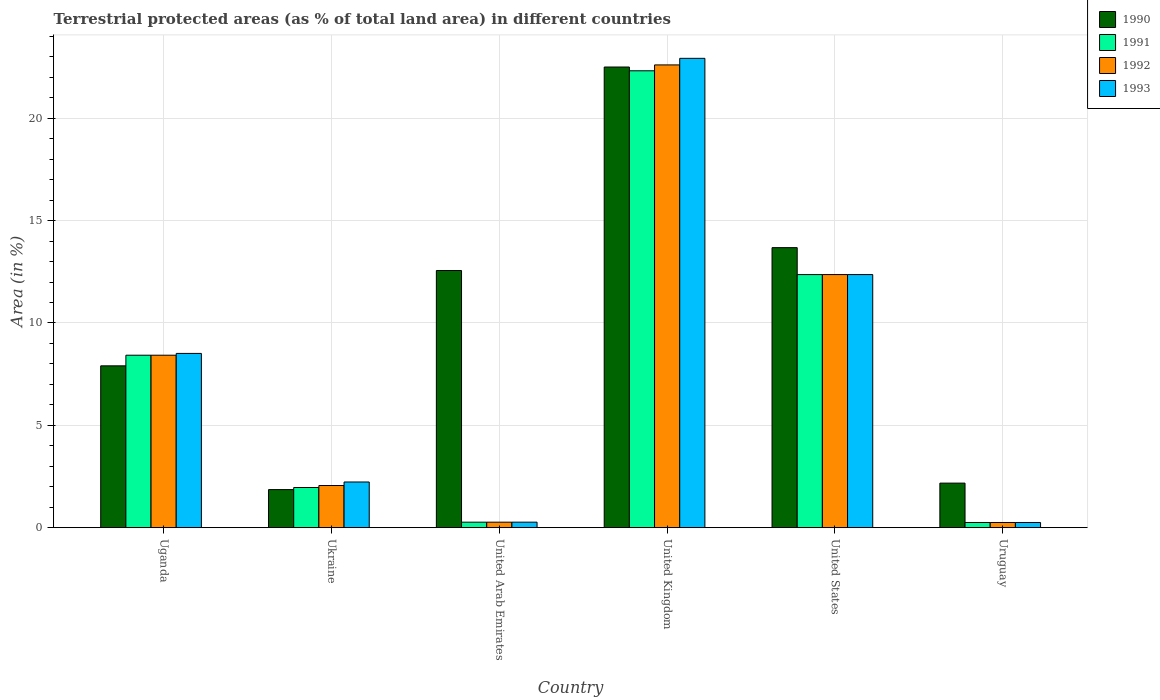How many groups of bars are there?
Provide a short and direct response. 6. Are the number of bars on each tick of the X-axis equal?
Provide a succinct answer. Yes. How many bars are there on the 4th tick from the left?
Make the answer very short. 4. In how many cases, is the number of bars for a given country not equal to the number of legend labels?
Your answer should be compact. 0. What is the percentage of terrestrial protected land in 1991 in Ukraine?
Make the answer very short. 1.96. Across all countries, what is the maximum percentage of terrestrial protected land in 1991?
Give a very brief answer. 22.32. Across all countries, what is the minimum percentage of terrestrial protected land in 1990?
Your response must be concise. 1.86. In which country was the percentage of terrestrial protected land in 1992 maximum?
Offer a very short reply. United Kingdom. In which country was the percentage of terrestrial protected land in 1993 minimum?
Your response must be concise. Uruguay. What is the total percentage of terrestrial protected land in 1991 in the graph?
Your response must be concise. 45.59. What is the difference between the percentage of terrestrial protected land in 1992 in Uganda and that in United Kingdom?
Your answer should be compact. -14.18. What is the difference between the percentage of terrestrial protected land in 1992 in Uruguay and the percentage of terrestrial protected land in 1990 in United States?
Your answer should be very brief. -13.43. What is the average percentage of terrestrial protected land in 1991 per country?
Offer a very short reply. 7.6. What is the difference between the percentage of terrestrial protected land of/in 1991 and percentage of terrestrial protected land of/in 1993 in United Arab Emirates?
Provide a succinct answer. -0. What is the ratio of the percentage of terrestrial protected land in 1990 in Ukraine to that in United Kingdom?
Provide a short and direct response. 0.08. Is the difference between the percentage of terrestrial protected land in 1991 in United Arab Emirates and United Kingdom greater than the difference between the percentage of terrestrial protected land in 1993 in United Arab Emirates and United Kingdom?
Ensure brevity in your answer.  Yes. What is the difference between the highest and the second highest percentage of terrestrial protected land in 1990?
Your response must be concise. -1.12. What is the difference between the highest and the lowest percentage of terrestrial protected land in 1993?
Your answer should be very brief. 22.68. What does the 4th bar from the left in Uruguay represents?
Your response must be concise. 1993. How many bars are there?
Provide a succinct answer. 24. How many countries are there in the graph?
Provide a succinct answer. 6. What is the difference between two consecutive major ticks on the Y-axis?
Offer a terse response. 5. How many legend labels are there?
Provide a short and direct response. 4. What is the title of the graph?
Your answer should be very brief. Terrestrial protected areas (as % of total land area) in different countries. Does "2007" appear as one of the legend labels in the graph?
Offer a terse response. No. What is the label or title of the X-axis?
Ensure brevity in your answer.  Country. What is the label or title of the Y-axis?
Make the answer very short. Area (in %). What is the Area (in %) of 1990 in Uganda?
Your response must be concise. 7.91. What is the Area (in %) in 1991 in Uganda?
Make the answer very short. 8.43. What is the Area (in %) of 1992 in Uganda?
Give a very brief answer. 8.43. What is the Area (in %) in 1993 in Uganda?
Make the answer very short. 8.51. What is the Area (in %) of 1990 in Ukraine?
Ensure brevity in your answer.  1.86. What is the Area (in %) in 1991 in Ukraine?
Provide a succinct answer. 1.96. What is the Area (in %) in 1992 in Ukraine?
Your answer should be compact. 2.06. What is the Area (in %) in 1993 in Ukraine?
Provide a short and direct response. 2.23. What is the Area (in %) of 1990 in United Arab Emirates?
Your answer should be compact. 12.56. What is the Area (in %) of 1991 in United Arab Emirates?
Make the answer very short. 0.27. What is the Area (in %) of 1992 in United Arab Emirates?
Offer a terse response. 0.27. What is the Area (in %) of 1993 in United Arab Emirates?
Keep it short and to the point. 0.27. What is the Area (in %) in 1990 in United Kingdom?
Give a very brief answer. 22.51. What is the Area (in %) of 1991 in United Kingdom?
Provide a short and direct response. 22.32. What is the Area (in %) of 1992 in United Kingdom?
Ensure brevity in your answer.  22.61. What is the Area (in %) in 1993 in United Kingdom?
Give a very brief answer. 22.93. What is the Area (in %) in 1990 in United States?
Give a very brief answer. 13.68. What is the Area (in %) in 1991 in United States?
Give a very brief answer. 12.36. What is the Area (in %) of 1992 in United States?
Provide a short and direct response. 12.36. What is the Area (in %) in 1993 in United States?
Offer a very short reply. 12.37. What is the Area (in %) of 1990 in Uruguay?
Your answer should be compact. 2.18. What is the Area (in %) in 1991 in Uruguay?
Make the answer very short. 0.25. What is the Area (in %) of 1992 in Uruguay?
Offer a terse response. 0.25. What is the Area (in %) in 1993 in Uruguay?
Offer a very short reply. 0.25. Across all countries, what is the maximum Area (in %) in 1990?
Your answer should be very brief. 22.51. Across all countries, what is the maximum Area (in %) of 1991?
Offer a terse response. 22.32. Across all countries, what is the maximum Area (in %) in 1992?
Your answer should be compact. 22.61. Across all countries, what is the maximum Area (in %) in 1993?
Provide a short and direct response. 22.93. Across all countries, what is the minimum Area (in %) in 1990?
Give a very brief answer. 1.86. Across all countries, what is the minimum Area (in %) of 1991?
Provide a short and direct response. 0.25. Across all countries, what is the minimum Area (in %) in 1992?
Provide a short and direct response. 0.25. Across all countries, what is the minimum Area (in %) in 1993?
Make the answer very short. 0.25. What is the total Area (in %) of 1990 in the graph?
Provide a short and direct response. 60.69. What is the total Area (in %) of 1991 in the graph?
Your answer should be compact. 45.59. What is the total Area (in %) in 1992 in the graph?
Ensure brevity in your answer.  45.97. What is the total Area (in %) of 1993 in the graph?
Provide a short and direct response. 46.56. What is the difference between the Area (in %) in 1990 in Uganda and that in Ukraine?
Offer a terse response. 6.05. What is the difference between the Area (in %) in 1991 in Uganda and that in Ukraine?
Your answer should be very brief. 6.46. What is the difference between the Area (in %) of 1992 in Uganda and that in Ukraine?
Keep it short and to the point. 6.37. What is the difference between the Area (in %) of 1993 in Uganda and that in Ukraine?
Make the answer very short. 6.28. What is the difference between the Area (in %) of 1990 in Uganda and that in United Arab Emirates?
Ensure brevity in your answer.  -4.66. What is the difference between the Area (in %) of 1991 in Uganda and that in United Arab Emirates?
Your response must be concise. 8.16. What is the difference between the Area (in %) of 1992 in Uganda and that in United Arab Emirates?
Your answer should be very brief. 8.16. What is the difference between the Area (in %) in 1993 in Uganda and that in United Arab Emirates?
Give a very brief answer. 8.25. What is the difference between the Area (in %) of 1990 in Uganda and that in United Kingdom?
Ensure brevity in your answer.  -14.6. What is the difference between the Area (in %) of 1991 in Uganda and that in United Kingdom?
Provide a short and direct response. -13.9. What is the difference between the Area (in %) in 1992 in Uganda and that in United Kingdom?
Provide a succinct answer. -14.18. What is the difference between the Area (in %) of 1993 in Uganda and that in United Kingdom?
Provide a succinct answer. -14.42. What is the difference between the Area (in %) of 1990 in Uganda and that in United States?
Your response must be concise. -5.77. What is the difference between the Area (in %) in 1991 in Uganda and that in United States?
Give a very brief answer. -3.94. What is the difference between the Area (in %) of 1992 in Uganda and that in United States?
Provide a short and direct response. -3.94. What is the difference between the Area (in %) of 1993 in Uganda and that in United States?
Your answer should be very brief. -3.85. What is the difference between the Area (in %) of 1990 in Uganda and that in Uruguay?
Provide a short and direct response. 5.73. What is the difference between the Area (in %) in 1991 in Uganda and that in Uruguay?
Provide a succinct answer. 8.17. What is the difference between the Area (in %) of 1992 in Uganda and that in Uruguay?
Your answer should be compact. 8.17. What is the difference between the Area (in %) in 1993 in Uganda and that in Uruguay?
Provide a succinct answer. 8.26. What is the difference between the Area (in %) of 1990 in Ukraine and that in United Arab Emirates?
Give a very brief answer. -10.7. What is the difference between the Area (in %) in 1991 in Ukraine and that in United Arab Emirates?
Your response must be concise. 1.69. What is the difference between the Area (in %) of 1992 in Ukraine and that in United Arab Emirates?
Keep it short and to the point. 1.79. What is the difference between the Area (in %) of 1993 in Ukraine and that in United Arab Emirates?
Provide a short and direct response. 1.96. What is the difference between the Area (in %) of 1990 in Ukraine and that in United Kingdom?
Your response must be concise. -20.65. What is the difference between the Area (in %) in 1991 in Ukraine and that in United Kingdom?
Give a very brief answer. -20.36. What is the difference between the Area (in %) in 1992 in Ukraine and that in United Kingdom?
Give a very brief answer. -20.55. What is the difference between the Area (in %) of 1993 in Ukraine and that in United Kingdom?
Your answer should be very brief. -20.7. What is the difference between the Area (in %) in 1990 in Ukraine and that in United States?
Keep it short and to the point. -11.82. What is the difference between the Area (in %) in 1991 in Ukraine and that in United States?
Your answer should be compact. -10.4. What is the difference between the Area (in %) in 1992 in Ukraine and that in United States?
Provide a succinct answer. -10.31. What is the difference between the Area (in %) of 1993 in Ukraine and that in United States?
Your answer should be compact. -10.13. What is the difference between the Area (in %) of 1990 in Ukraine and that in Uruguay?
Your answer should be compact. -0.32. What is the difference between the Area (in %) of 1991 in Ukraine and that in Uruguay?
Provide a succinct answer. 1.71. What is the difference between the Area (in %) in 1992 in Ukraine and that in Uruguay?
Your answer should be compact. 1.81. What is the difference between the Area (in %) in 1993 in Ukraine and that in Uruguay?
Provide a succinct answer. 1.98. What is the difference between the Area (in %) in 1990 in United Arab Emirates and that in United Kingdom?
Give a very brief answer. -9.94. What is the difference between the Area (in %) in 1991 in United Arab Emirates and that in United Kingdom?
Your response must be concise. -22.05. What is the difference between the Area (in %) in 1992 in United Arab Emirates and that in United Kingdom?
Your answer should be compact. -22.34. What is the difference between the Area (in %) of 1993 in United Arab Emirates and that in United Kingdom?
Provide a short and direct response. -22.66. What is the difference between the Area (in %) of 1990 in United Arab Emirates and that in United States?
Make the answer very short. -1.12. What is the difference between the Area (in %) in 1991 in United Arab Emirates and that in United States?
Provide a short and direct response. -12.1. What is the difference between the Area (in %) in 1992 in United Arab Emirates and that in United States?
Ensure brevity in your answer.  -12.1. What is the difference between the Area (in %) of 1993 in United Arab Emirates and that in United States?
Offer a very short reply. -12.1. What is the difference between the Area (in %) in 1990 in United Arab Emirates and that in Uruguay?
Provide a succinct answer. 10.39. What is the difference between the Area (in %) of 1991 in United Arab Emirates and that in Uruguay?
Make the answer very short. 0.02. What is the difference between the Area (in %) of 1992 in United Arab Emirates and that in Uruguay?
Give a very brief answer. 0.02. What is the difference between the Area (in %) in 1993 in United Arab Emirates and that in Uruguay?
Your answer should be very brief. 0.02. What is the difference between the Area (in %) in 1990 in United Kingdom and that in United States?
Your response must be concise. 8.83. What is the difference between the Area (in %) in 1991 in United Kingdom and that in United States?
Give a very brief answer. 9.96. What is the difference between the Area (in %) of 1992 in United Kingdom and that in United States?
Make the answer very short. 10.24. What is the difference between the Area (in %) of 1993 in United Kingdom and that in United States?
Offer a very short reply. 10.56. What is the difference between the Area (in %) of 1990 in United Kingdom and that in Uruguay?
Your answer should be very brief. 20.33. What is the difference between the Area (in %) of 1991 in United Kingdom and that in Uruguay?
Your answer should be very brief. 22.07. What is the difference between the Area (in %) in 1992 in United Kingdom and that in Uruguay?
Offer a terse response. 22.36. What is the difference between the Area (in %) in 1993 in United Kingdom and that in Uruguay?
Your answer should be compact. 22.68. What is the difference between the Area (in %) of 1990 in United States and that in Uruguay?
Keep it short and to the point. 11.5. What is the difference between the Area (in %) of 1991 in United States and that in Uruguay?
Ensure brevity in your answer.  12.11. What is the difference between the Area (in %) of 1992 in United States and that in Uruguay?
Keep it short and to the point. 12.11. What is the difference between the Area (in %) of 1993 in United States and that in Uruguay?
Keep it short and to the point. 12.11. What is the difference between the Area (in %) of 1990 in Uganda and the Area (in %) of 1991 in Ukraine?
Ensure brevity in your answer.  5.94. What is the difference between the Area (in %) of 1990 in Uganda and the Area (in %) of 1992 in Ukraine?
Ensure brevity in your answer.  5.85. What is the difference between the Area (in %) of 1990 in Uganda and the Area (in %) of 1993 in Ukraine?
Keep it short and to the point. 5.68. What is the difference between the Area (in %) in 1991 in Uganda and the Area (in %) in 1992 in Ukraine?
Offer a very short reply. 6.37. What is the difference between the Area (in %) of 1991 in Uganda and the Area (in %) of 1993 in Ukraine?
Provide a succinct answer. 6.19. What is the difference between the Area (in %) in 1992 in Uganda and the Area (in %) in 1993 in Ukraine?
Your response must be concise. 6.19. What is the difference between the Area (in %) of 1990 in Uganda and the Area (in %) of 1991 in United Arab Emirates?
Your answer should be very brief. 7.64. What is the difference between the Area (in %) in 1990 in Uganda and the Area (in %) in 1992 in United Arab Emirates?
Ensure brevity in your answer.  7.64. What is the difference between the Area (in %) in 1990 in Uganda and the Area (in %) in 1993 in United Arab Emirates?
Provide a succinct answer. 7.64. What is the difference between the Area (in %) in 1991 in Uganda and the Area (in %) in 1992 in United Arab Emirates?
Your response must be concise. 8.16. What is the difference between the Area (in %) in 1991 in Uganda and the Area (in %) in 1993 in United Arab Emirates?
Your answer should be compact. 8.16. What is the difference between the Area (in %) of 1992 in Uganda and the Area (in %) of 1993 in United Arab Emirates?
Offer a very short reply. 8.16. What is the difference between the Area (in %) of 1990 in Uganda and the Area (in %) of 1991 in United Kingdom?
Offer a terse response. -14.42. What is the difference between the Area (in %) of 1990 in Uganda and the Area (in %) of 1992 in United Kingdom?
Give a very brief answer. -14.7. What is the difference between the Area (in %) in 1990 in Uganda and the Area (in %) in 1993 in United Kingdom?
Offer a terse response. -15.02. What is the difference between the Area (in %) in 1991 in Uganda and the Area (in %) in 1992 in United Kingdom?
Make the answer very short. -14.18. What is the difference between the Area (in %) in 1991 in Uganda and the Area (in %) in 1993 in United Kingdom?
Make the answer very short. -14.5. What is the difference between the Area (in %) of 1992 in Uganda and the Area (in %) of 1993 in United Kingdom?
Give a very brief answer. -14.5. What is the difference between the Area (in %) in 1990 in Uganda and the Area (in %) in 1991 in United States?
Give a very brief answer. -4.46. What is the difference between the Area (in %) in 1990 in Uganda and the Area (in %) in 1992 in United States?
Your answer should be very brief. -4.46. What is the difference between the Area (in %) of 1990 in Uganda and the Area (in %) of 1993 in United States?
Your answer should be very brief. -4.46. What is the difference between the Area (in %) in 1991 in Uganda and the Area (in %) in 1992 in United States?
Ensure brevity in your answer.  -3.94. What is the difference between the Area (in %) in 1991 in Uganda and the Area (in %) in 1993 in United States?
Provide a short and direct response. -3.94. What is the difference between the Area (in %) of 1992 in Uganda and the Area (in %) of 1993 in United States?
Provide a succinct answer. -3.94. What is the difference between the Area (in %) in 1990 in Uganda and the Area (in %) in 1991 in Uruguay?
Ensure brevity in your answer.  7.65. What is the difference between the Area (in %) of 1990 in Uganda and the Area (in %) of 1992 in Uruguay?
Your answer should be compact. 7.65. What is the difference between the Area (in %) of 1990 in Uganda and the Area (in %) of 1993 in Uruguay?
Your answer should be very brief. 7.65. What is the difference between the Area (in %) in 1991 in Uganda and the Area (in %) in 1992 in Uruguay?
Provide a succinct answer. 8.17. What is the difference between the Area (in %) of 1991 in Uganda and the Area (in %) of 1993 in Uruguay?
Offer a terse response. 8.17. What is the difference between the Area (in %) in 1992 in Uganda and the Area (in %) in 1993 in Uruguay?
Your answer should be compact. 8.17. What is the difference between the Area (in %) in 1990 in Ukraine and the Area (in %) in 1991 in United Arab Emirates?
Make the answer very short. 1.59. What is the difference between the Area (in %) in 1990 in Ukraine and the Area (in %) in 1992 in United Arab Emirates?
Ensure brevity in your answer.  1.59. What is the difference between the Area (in %) of 1990 in Ukraine and the Area (in %) of 1993 in United Arab Emirates?
Offer a very short reply. 1.59. What is the difference between the Area (in %) in 1991 in Ukraine and the Area (in %) in 1992 in United Arab Emirates?
Provide a short and direct response. 1.69. What is the difference between the Area (in %) of 1991 in Ukraine and the Area (in %) of 1993 in United Arab Emirates?
Your answer should be very brief. 1.69. What is the difference between the Area (in %) of 1992 in Ukraine and the Area (in %) of 1993 in United Arab Emirates?
Your answer should be very brief. 1.79. What is the difference between the Area (in %) of 1990 in Ukraine and the Area (in %) of 1991 in United Kingdom?
Ensure brevity in your answer.  -20.46. What is the difference between the Area (in %) of 1990 in Ukraine and the Area (in %) of 1992 in United Kingdom?
Your answer should be very brief. -20.75. What is the difference between the Area (in %) in 1990 in Ukraine and the Area (in %) in 1993 in United Kingdom?
Make the answer very short. -21.07. What is the difference between the Area (in %) of 1991 in Ukraine and the Area (in %) of 1992 in United Kingdom?
Your answer should be very brief. -20.65. What is the difference between the Area (in %) in 1991 in Ukraine and the Area (in %) in 1993 in United Kingdom?
Your answer should be compact. -20.97. What is the difference between the Area (in %) in 1992 in Ukraine and the Area (in %) in 1993 in United Kingdom?
Your answer should be very brief. -20.87. What is the difference between the Area (in %) of 1990 in Ukraine and the Area (in %) of 1991 in United States?
Offer a very short reply. -10.5. What is the difference between the Area (in %) of 1990 in Ukraine and the Area (in %) of 1992 in United States?
Keep it short and to the point. -10.51. What is the difference between the Area (in %) of 1990 in Ukraine and the Area (in %) of 1993 in United States?
Make the answer very short. -10.51. What is the difference between the Area (in %) of 1991 in Ukraine and the Area (in %) of 1992 in United States?
Keep it short and to the point. -10.4. What is the difference between the Area (in %) in 1991 in Ukraine and the Area (in %) in 1993 in United States?
Ensure brevity in your answer.  -10.4. What is the difference between the Area (in %) of 1992 in Ukraine and the Area (in %) of 1993 in United States?
Make the answer very short. -10.31. What is the difference between the Area (in %) of 1990 in Ukraine and the Area (in %) of 1991 in Uruguay?
Offer a very short reply. 1.61. What is the difference between the Area (in %) of 1990 in Ukraine and the Area (in %) of 1992 in Uruguay?
Offer a very short reply. 1.61. What is the difference between the Area (in %) in 1990 in Ukraine and the Area (in %) in 1993 in Uruguay?
Make the answer very short. 1.61. What is the difference between the Area (in %) in 1991 in Ukraine and the Area (in %) in 1992 in Uruguay?
Your answer should be very brief. 1.71. What is the difference between the Area (in %) of 1991 in Ukraine and the Area (in %) of 1993 in Uruguay?
Offer a terse response. 1.71. What is the difference between the Area (in %) in 1992 in Ukraine and the Area (in %) in 1993 in Uruguay?
Ensure brevity in your answer.  1.81. What is the difference between the Area (in %) of 1990 in United Arab Emirates and the Area (in %) of 1991 in United Kingdom?
Provide a short and direct response. -9.76. What is the difference between the Area (in %) of 1990 in United Arab Emirates and the Area (in %) of 1992 in United Kingdom?
Offer a terse response. -10.05. What is the difference between the Area (in %) of 1990 in United Arab Emirates and the Area (in %) of 1993 in United Kingdom?
Your answer should be very brief. -10.37. What is the difference between the Area (in %) in 1991 in United Arab Emirates and the Area (in %) in 1992 in United Kingdom?
Provide a succinct answer. -22.34. What is the difference between the Area (in %) in 1991 in United Arab Emirates and the Area (in %) in 1993 in United Kingdom?
Offer a terse response. -22.66. What is the difference between the Area (in %) in 1992 in United Arab Emirates and the Area (in %) in 1993 in United Kingdom?
Your response must be concise. -22.66. What is the difference between the Area (in %) of 1990 in United Arab Emirates and the Area (in %) of 1991 in United States?
Provide a short and direct response. 0.2. What is the difference between the Area (in %) of 1990 in United Arab Emirates and the Area (in %) of 1992 in United States?
Offer a very short reply. 0.2. What is the difference between the Area (in %) in 1990 in United Arab Emirates and the Area (in %) in 1993 in United States?
Ensure brevity in your answer.  0.2. What is the difference between the Area (in %) in 1991 in United Arab Emirates and the Area (in %) in 1992 in United States?
Make the answer very short. -12.1. What is the difference between the Area (in %) of 1991 in United Arab Emirates and the Area (in %) of 1993 in United States?
Make the answer very short. -12.1. What is the difference between the Area (in %) in 1992 in United Arab Emirates and the Area (in %) in 1993 in United States?
Your answer should be compact. -12.1. What is the difference between the Area (in %) of 1990 in United Arab Emirates and the Area (in %) of 1991 in Uruguay?
Keep it short and to the point. 12.31. What is the difference between the Area (in %) of 1990 in United Arab Emirates and the Area (in %) of 1992 in Uruguay?
Your response must be concise. 12.31. What is the difference between the Area (in %) in 1990 in United Arab Emirates and the Area (in %) in 1993 in Uruguay?
Ensure brevity in your answer.  12.31. What is the difference between the Area (in %) of 1991 in United Arab Emirates and the Area (in %) of 1992 in Uruguay?
Give a very brief answer. 0.02. What is the difference between the Area (in %) of 1991 in United Arab Emirates and the Area (in %) of 1993 in Uruguay?
Make the answer very short. 0.02. What is the difference between the Area (in %) in 1992 in United Arab Emirates and the Area (in %) in 1993 in Uruguay?
Keep it short and to the point. 0.02. What is the difference between the Area (in %) of 1990 in United Kingdom and the Area (in %) of 1991 in United States?
Make the answer very short. 10.14. What is the difference between the Area (in %) of 1990 in United Kingdom and the Area (in %) of 1992 in United States?
Give a very brief answer. 10.14. What is the difference between the Area (in %) in 1990 in United Kingdom and the Area (in %) in 1993 in United States?
Ensure brevity in your answer.  10.14. What is the difference between the Area (in %) in 1991 in United Kingdom and the Area (in %) in 1992 in United States?
Provide a succinct answer. 9.96. What is the difference between the Area (in %) of 1991 in United Kingdom and the Area (in %) of 1993 in United States?
Provide a short and direct response. 9.96. What is the difference between the Area (in %) of 1992 in United Kingdom and the Area (in %) of 1993 in United States?
Provide a short and direct response. 10.24. What is the difference between the Area (in %) in 1990 in United Kingdom and the Area (in %) in 1991 in Uruguay?
Your answer should be compact. 22.25. What is the difference between the Area (in %) in 1990 in United Kingdom and the Area (in %) in 1992 in Uruguay?
Keep it short and to the point. 22.25. What is the difference between the Area (in %) of 1990 in United Kingdom and the Area (in %) of 1993 in Uruguay?
Your answer should be compact. 22.25. What is the difference between the Area (in %) in 1991 in United Kingdom and the Area (in %) in 1992 in Uruguay?
Your answer should be very brief. 22.07. What is the difference between the Area (in %) in 1991 in United Kingdom and the Area (in %) in 1993 in Uruguay?
Provide a succinct answer. 22.07. What is the difference between the Area (in %) of 1992 in United Kingdom and the Area (in %) of 1993 in Uruguay?
Keep it short and to the point. 22.36. What is the difference between the Area (in %) in 1990 in United States and the Area (in %) in 1991 in Uruguay?
Give a very brief answer. 13.43. What is the difference between the Area (in %) of 1990 in United States and the Area (in %) of 1992 in Uruguay?
Make the answer very short. 13.43. What is the difference between the Area (in %) in 1990 in United States and the Area (in %) in 1993 in Uruguay?
Your answer should be very brief. 13.43. What is the difference between the Area (in %) of 1991 in United States and the Area (in %) of 1992 in Uruguay?
Make the answer very short. 12.11. What is the difference between the Area (in %) in 1991 in United States and the Area (in %) in 1993 in Uruguay?
Keep it short and to the point. 12.11. What is the difference between the Area (in %) of 1992 in United States and the Area (in %) of 1993 in Uruguay?
Keep it short and to the point. 12.11. What is the average Area (in %) in 1990 per country?
Make the answer very short. 10.11. What is the average Area (in %) of 1991 per country?
Your answer should be compact. 7.6. What is the average Area (in %) of 1992 per country?
Your answer should be compact. 7.66. What is the average Area (in %) of 1993 per country?
Provide a short and direct response. 7.76. What is the difference between the Area (in %) in 1990 and Area (in %) in 1991 in Uganda?
Make the answer very short. -0.52. What is the difference between the Area (in %) in 1990 and Area (in %) in 1992 in Uganda?
Offer a very short reply. -0.52. What is the difference between the Area (in %) in 1990 and Area (in %) in 1993 in Uganda?
Offer a very short reply. -0.61. What is the difference between the Area (in %) in 1991 and Area (in %) in 1993 in Uganda?
Your answer should be compact. -0.09. What is the difference between the Area (in %) in 1992 and Area (in %) in 1993 in Uganda?
Offer a very short reply. -0.09. What is the difference between the Area (in %) of 1990 and Area (in %) of 1991 in Ukraine?
Give a very brief answer. -0.1. What is the difference between the Area (in %) of 1990 and Area (in %) of 1992 in Ukraine?
Your answer should be compact. -0.2. What is the difference between the Area (in %) in 1990 and Area (in %) in 1993 in Ukraine?
Keep it short and to the point. -0.37. What is the difference between the Area (in %) in 1991 and Area (in %) in 1992 in Ukraine?
Offer a terse response. -0.1. What is the difference between the Area (in %) of 1991 and Area (in %) of 1993 in Ukraine?
Ensure brevity in your answer.  -0.27. What is the difference between the Area (in %) in 1992 and Area (in %) in 1993 in Ukraine?
Your response must be concise. -0.17. What is the difference between the Area (in %) in 1990 and Area (in %) in 1991 in United Arab Emirates?
Give a very brief answer. 12.3. What is the difference between the Area (in %) of 1990 and Area (in %) of 1992 in United Arab Emirates?
Provide a succinct answer. 12.3. What is the difference between the Area (in %) of 1990 and Area (in %) of 1993 in United Arab Emirates?
Keep it short and to the point. 12.29. What is the difference between the Area (in %) in 1991 and Area (in %) in 1993 in United Arab Emirates?
Offer a terse response. -0. What is the difference between the Area (in %) of 1992 and Area (in %) of 1993 in United Arab Emirates?
Your answer should be compact. -0. What is the difference between the Area (in %) of 1990 and Area (in %) of 1991 in United Kingdom?
Provide a short and direct response. 0.18. What is the difference between the Area (in %) of 1990 and Area (in %) of 1992 in United Kingdom?
Give a very brief answer. -0.1. What is the difference between the Area (in %) of 1990 and Area (in %) of 1993 in United Kingdom?
Your response must be concise. -0.42. What is the difference between the Area (in %) in 1991 and Area (in %) in 1992 in United Kingdom?
Your answer should be very brief. -0.29. What is the difference between the Area (in %) in 1991 and Area (in %) in 1993 in United Kingdom?
Your answer should be very brief. -0.61. What is the difference between the Area (in %) of 1992 and Area (in %) of 1993 in United Kingdom?
Ensure brevity in your answer.  -0.32. What is the difference between the Area (in %) in 1990 and Area (in %) in 1991 in United States?
Your response must be concise. 1.32. What is the difference between the Area (in %) of 1990 and Area (in %) of 1992 in United States?
Offer a terse response. 1.32. What is the difference between the Area (in %) of 1990 and Area (in %) of 1993 in United States?
Ensure brevity in your answer.  1.31. What is the difference between the Area (in %) of 1991 and Area (in %) of 1992 in United States?
Make the answer very short. -0. What is the difference between the Area (in %) of 1991 and Area (in %) of 1993 in United States?
Provide a succinct answer. -0. What is the difference between the Area (in %) of 1992 and Area (in %) of 1993 in United States?
Provide a short and direct response. -0. What is the difference between the Area (in %) of 1990 and Area (in %) of 1991 in Uruguay?
Give a very brief answer. 1.92. What is the difference between the Area (in %) of 1990 and Area (in %) of 1992 in Uruguay?
Give a very brief answer. 1.92. What is the difference between the Area (in %) of 1990 and Area (in %) of 1993 in Uruguay?
Provide a succinct answer. 1.92. What is the difference between the Area (in %) in 1991 and Area (in %) in 1992 in Uruguay?
Ensure brevity in your answer.  -0. What is the difference between the Area (in %) in 1991 and Area (in %) in 1993 in Uruguay?
Offer a terse response. -0. What is the difference between the Area (in %) in 1992 and Area (in %) in 1993 in Uruguay?
Your answer should be very brief. 0. What is the ratio of the Area (in %) of 1990 in Uganda to that in Ukraine?
Give a very brief answer. 4.25. What is the ratio of the Area (in %) of 1991 in Uganda to that in Ukraine?
Keep it short and to the point. 4.29. What is the ratio of the Area (in %) of 1992 in Uganda to that in Ukraine?
Give a very brief answer. 4.09. What is the ratio of the Area (in %) in 1993 in Uganda to that in Ukraine?
Provide a short and direct response. 3.82. What is the ratio of the Area (in %) in 1990 in Uganda to that in United Arab Emirates?
Provide a short and direct response. 0.63. What is the ratio of the Area (in %) in 1991 in Uganda to that in United Arab Emirates?
Your answer should be compact. 31.57. What is the ratio of the Area (in %) of 1992 in Uganda to that in United Arab Emirates?
Your answer should be compact. 31.57. What is the ratio of the Area (in %) in 1993 in Uganda to that in United Arab Emirates?
Ensure brevity in your answer.  31.81. What is the ratio of the Area (in %) in 1990 in Uganda to that in United Kingdom?
Offer a terse response. 0.35. What is the ratio of the Area (in %) of 1991 in Uganda to that in United Kingdom?
Offer a terse response. 0.38. What is the ratio of the Area (in %) of 1992 in Uganda to that in United Kingdom?
Provide a succinct answer. 0.37. What is the ratio of the Area (in %) of 1993 in Uganda to that in United Kingdom?
Your response must be concise. 0.37. What is the ratio of the Area (in %) in 1990 in Uganda to that in United States?
Your answer should be compact. 0.58. What is the ratio of the Area (in %) in 1991 in Uganda to that in United States?
Your answer should be compact. 0.68. What is the ratio of the Area (in %) in 1992 in Uganda to that in United States?
Your answer should be very brief. 0.68. What is the ratio of the Area (in %) of 1993 in Uganda to that in United States?
Your response must be concise. 0.69. What is the ratio of the Area (in %) in 1990 in Uganda to that in Uruguay?
Provide a short and direct response. 3.63. What is the ratio of the Area (in %) in 1991 in Uganda to that in Uruguay?
Provide a short and direct response. 33.58. What is the ratio of the Area (in %) in 1992 in Uganda to that in Uruguay?
Give a very brief answer. 33.57. What is the ratio of the Area (in %) of 1993 in Uganda to that in Uruguay?
Offer a terse response. 33.92. What is the ratio of the Area (in %) of 1990 in Ukraine to that in United Arab Emirates?
Your answer should be very brief. 0.15. What is the ratio of the Area (in %) of 1991 in Ukraine to that in United Arab Emirates?
Ensure brevity in your answer.  7.35. What is the ratio of the Area (in %) of 1992 in Ukraine to that in United Arab Emirates?
Give a very brief answer. 7.71. What is the ratio of the Area (in %) of 1993 in Ukraine to that in United Arab Emirates?
Offer a terse response. 8.33. What is the ratio of the Area (in %) in 1990 in Ukraine to that in United Kingdom?
Your answer should be compact. 0.08. What is the ratio of the Area (in %) in 1991 in Ukraine to that in United Kingdom?
Ensure brevity in your answer.  0.09. What is the ratio of the Area (in %) of 1992 in Ukraine to that in United Kingdom?
Provide a short and direct response. 0.09. What is the ratio of the Area (in %) in 1993 in Ukraine to that in United Kingdom?
Your answer should be very brief. 0.1. What is the ratio of the Area (in %) of 1990 in Ukraine to that in United States?
Ensure brevity in your answer.  0.14. What is the ratio of the Area (in %) in 1991 in Ukraine to that in United States?
Offer a very short reply. 0.16. What is the ratio of the Area (in %) in 1992 in Ukraine to that in United States?
Your answer should be very brief. 0.17. What is the ratio of the Area (in %) of 1993 in Ukraine to that in United States?
Your answer should be compact. 0.18. What is the ratio of the Area (in %) in 1990 in Ukraine to that in Uruguay?
Your answer should be very brief. 0.85. What is the ratio of the Area (in %) of 1991 in Ukraine to that in Uruguay?
Provide a succinct answer. 7.82. What is the ratio of the Area (in %) in 1992 in Ukraine to that in Uruguay?
Ensure brevity in your answer.  8.2. What is the ratio of the Area (in %) in 1993 in Ukraine to that in Uruguay?
Your answer should be compact. 8.89. What is the ratio of the Area (in %) in 1990 in United Arab Emirates to that in United Kingdom?
Your response must be concise. 0.56. What is the ratio of the Area (in %) of 1991 in United Arab Emirates to that in United Kingdom?
Provide a succinct answer. 0.01. What is the ratio of the Area (in %) in 1992 in United Arab Emirates to that in United Kingdom?
Keep it short and to the point. 0.01. What is the ratio of the Area (in %) in 1993 in United Arab Emirates to that in United Kingdom?
Your response must be concise. 0.01. What is the ratio of the Area (in %) of 1990 in United Arab Emirates to that in United States?
Keep it short and to the point. 0.92. What is the ratio of the Area (in %) of 1991 in United Arab Emirates to that in United States?
Provide a succinct answer. 0.02. What is the ratio of the Area (in %) in 1992 in United Arab Emirates to that in United States?
Your answer should be very brief. 0.02. What is the ratio of the Area (in %) in 1993 in United Arab Emirates to that in United States?
Offer a terse response. 0.02. What is the ratio of the Area (in %) in 1990 in United Arab Emirates to that in Uruguay?
Offer a very short reply. 5.77. What is the ratio of the Area (in %) of 1991 in United Arab Emirates to that in Uruguay?
Offer a terse response. 1.06. What is the ratio of the Area (in %) of 1992 in United Arab Emirates to that in Uruguay?
Offer a terse response. 1.06. What is the ratio of the Area (in %) of 1993 in United Arab Emirates to that in Uruguay?
Make the answer very short. 1.07. What is the ratio of the Area (in %) of 1990 in United Kingdom to that in United States?
Your answer should be compact. 1.65. What is the ratio of the Area (in %) in 1991 in United Kingdom to that in United States?
Your response must be concise. 1.81. What is the ratio of the Area (in %) of 1992 in United Kingdom to that in United States?
Your answer should be compact. 1.83. What is the ratio of the Area (in %) in 1993 in United Kingdom to that in United States?
Ensure brevity in your answer.  1.85. What is the ratio of the Area (in %) of 1990 in United Kingdom to that in Uruguay?
Your answer should be compact. 10.34. What is the ratio of the Area (in %) in 1991 in United Kingdom to that in Uruguay?
Ensure brevity in your answer.  88.97. What is the ratio of the Area (in %) of 1992 in United Kingdom to that in Uruguay?
Your response must be concise. 90.08. What is the ratio of the Area (in %) in 1993 in United Kingdom to that in Uruguay?
Offer a very short reply. 91.36. What is the ratio of the Area (in %) in 1990 in United States to that in Uruguay?
Offer a terse response. 6.29. What is the ratio of the Area (in %) of 1991 in United States to that in Uruguay?
Your answer should be compact. 49.28. What is the ratio of the Area (in %) in 1992 in United States to that in Uruguay?
Keep it short and to the point. 49.27. What is the ratio of the Area (in %) in 1993 in United States to that in Uruguay?
Keep it short and to the point. 49.27. What is the difference between the highest and the second highest Area (in %) of 1990?
Your answer should be very brief. 8.83. What is the difference between the highest and the second highest Area (in %) of 1991?
Keep it short and to the point. 9.96. What is the difference between the highest and the second highest Area (in %) in 1992?
Your response must be concise. 10.24. What is the difference between the highest and the second highest Area (in %) of 1993?
Provide a succinct answer. 10.56. What is the difference between the highest and the lowest Area (in %) of 1990?
Provide a short and direct response. 20.65. What is the difference between the highest and the lowest Area (in %) in 1991?
Ensure brevity in your answer.  22.07. What is the difference between the highest and the lowest Area (in %) of 1992?
Give a very brief answer. 22.36. What is the difference between the highest and the lowest Area (in %) of 1993?
Offer a very short reply. 22.68. 